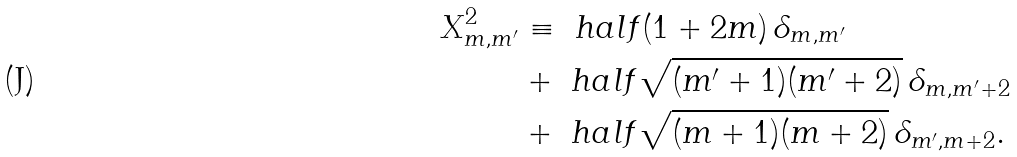Convert formula to latex. <formula><loc_0><loc_0><loc_500><loc_500>X ^ { 2 } _ { m , m ^ { \prime } } & \equiv \ h a l f ( 1 + 2 m ) \, \delta _ { m , m ^ { \prime } } \\ & + \ h a l f \sqrt { ( m ^ { \prime } + 1 ) ( m ^ { \prime } + 2 ) } \, \delta _ { m , m ^ { \prime } + 2 } \\ & + \ h a l f \sqrt { ( m + 1 ) ( m + 2 ) } \, \delta _ { m ^ { \prime } , m + 2 } .</formula> 